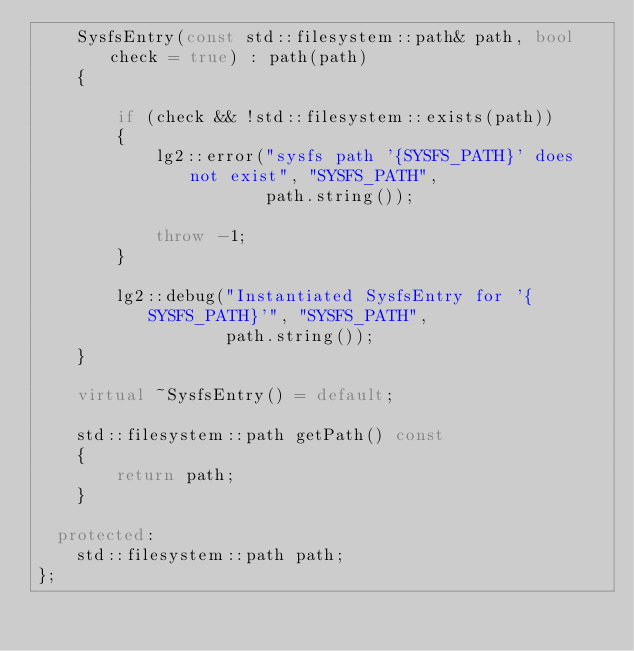Convert code to text. <code><loc_0><loc_0><loc_500><loc_500><_C++_>    SysfsEntry(const std::filesystem::path& path, bool check = true) : path(path)
    {

        if (check && !std::filesystem::exists(path))
        {
            lg2::error("sysfs path '{SYSFS_PATH}' does not exist", "SYSFS_PATH",
                       path.string());

            throw -1;
        }

        lg2::debug("Instantiated SysfsEntry for '{SYSFS_PATH}'", "SYSFS_PATH",
                   path.string());
    }

    virtual ~SysfsEntry() = default;

    std::filesystem::path getPath() const
    {
        return path;
    }

  protected:
    std::filesystem::path path;
};
</code> 